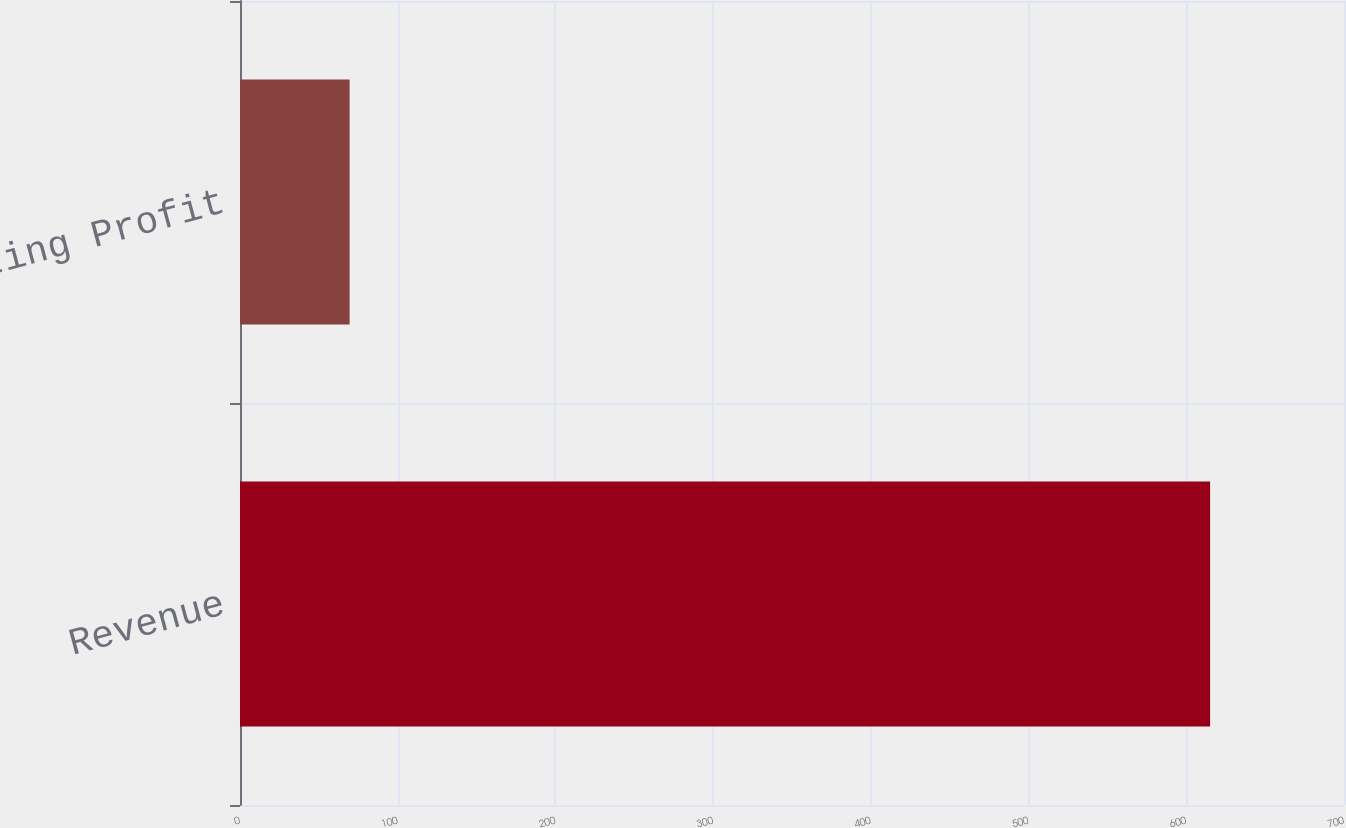<chart> <loc_0><loc_0><loc_500><loc_500><bar_chart><fcel>Revenue<fcel>Operating Profit<nl><fcel>615.1<fcel>69.5<nl></chart> 